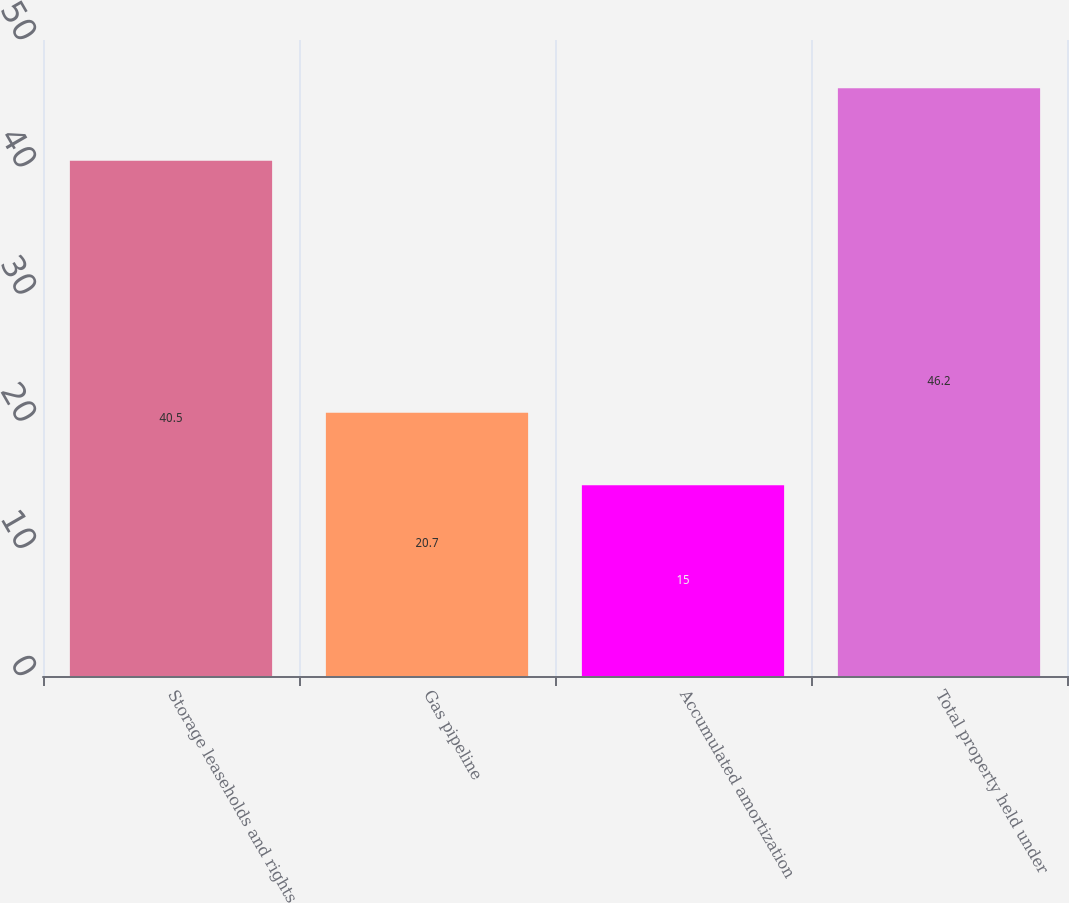Convert chart to OTSL. <chart><loc_0><loc_0><loc_500><loc_500><bar_chart><fcel>Storage leaseholds and rights<fcel>Gas pipeline<fcel>Accumulated amortization<fcel>Total property held under<nl><fcel>40.5<fcel>20.7<fcel>15<fcel>46.2<nl></chart> 